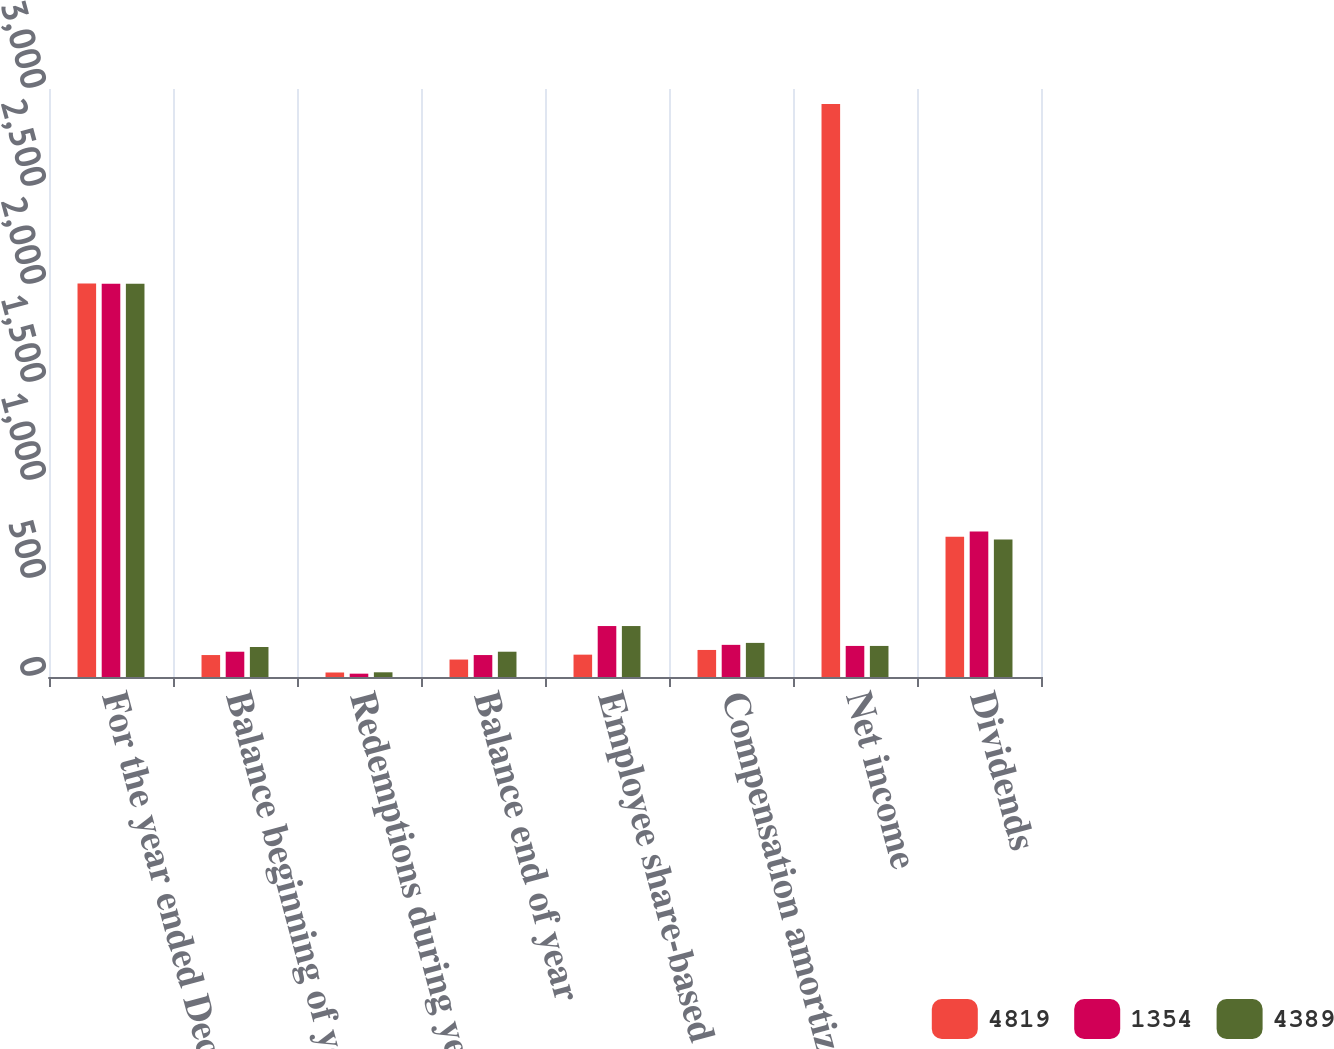Convert chart to OTSL. <chart><loc_0><loc_0><loc_500><loc_500><stacked_bar_chart><ecel><fcel>For the year ended December 31<fcel>Balance beginning of year<fcel>Redemptions during year<fcel>Balance end of year<fcel>Employee share-based<fcel>Compensation amortization<fcel>Net income<fcel>Dividends<nl><fcel>4819<fcel>2008<fcel>112<fcel>23<fcel>89<fcel>114<fcel>138<fcel>2924<fcel>715<nl><fcel>1354<fcel>2007<fcel>129<fcel>17<fcel>112<fcel>260<fcel>164<fcel>158.5<fcel>742<nl><fcel>4389<fcel>2006<fcel>153<fcel>24<fcel>129<fcel>260<fcel>174<fcel>158.5<fcel>701<nl></chart> 